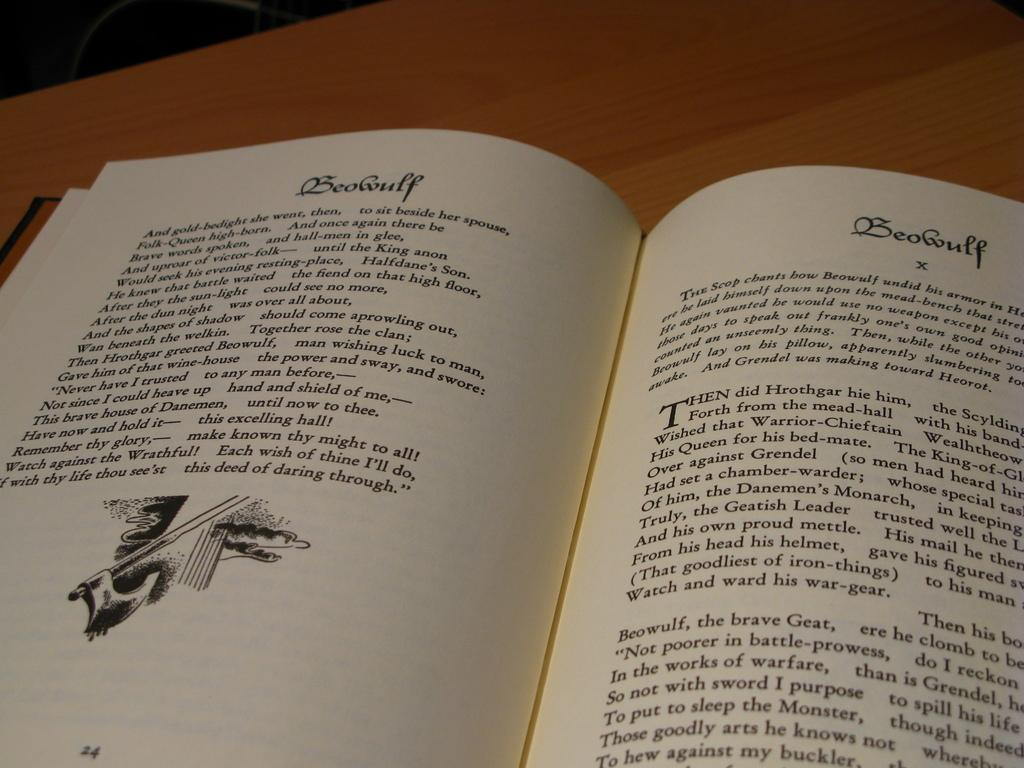<image>
Share a concise interpretation of the image provided. The book is open to page 24 of Beowulf, which features a small illustration of a hatchet. 